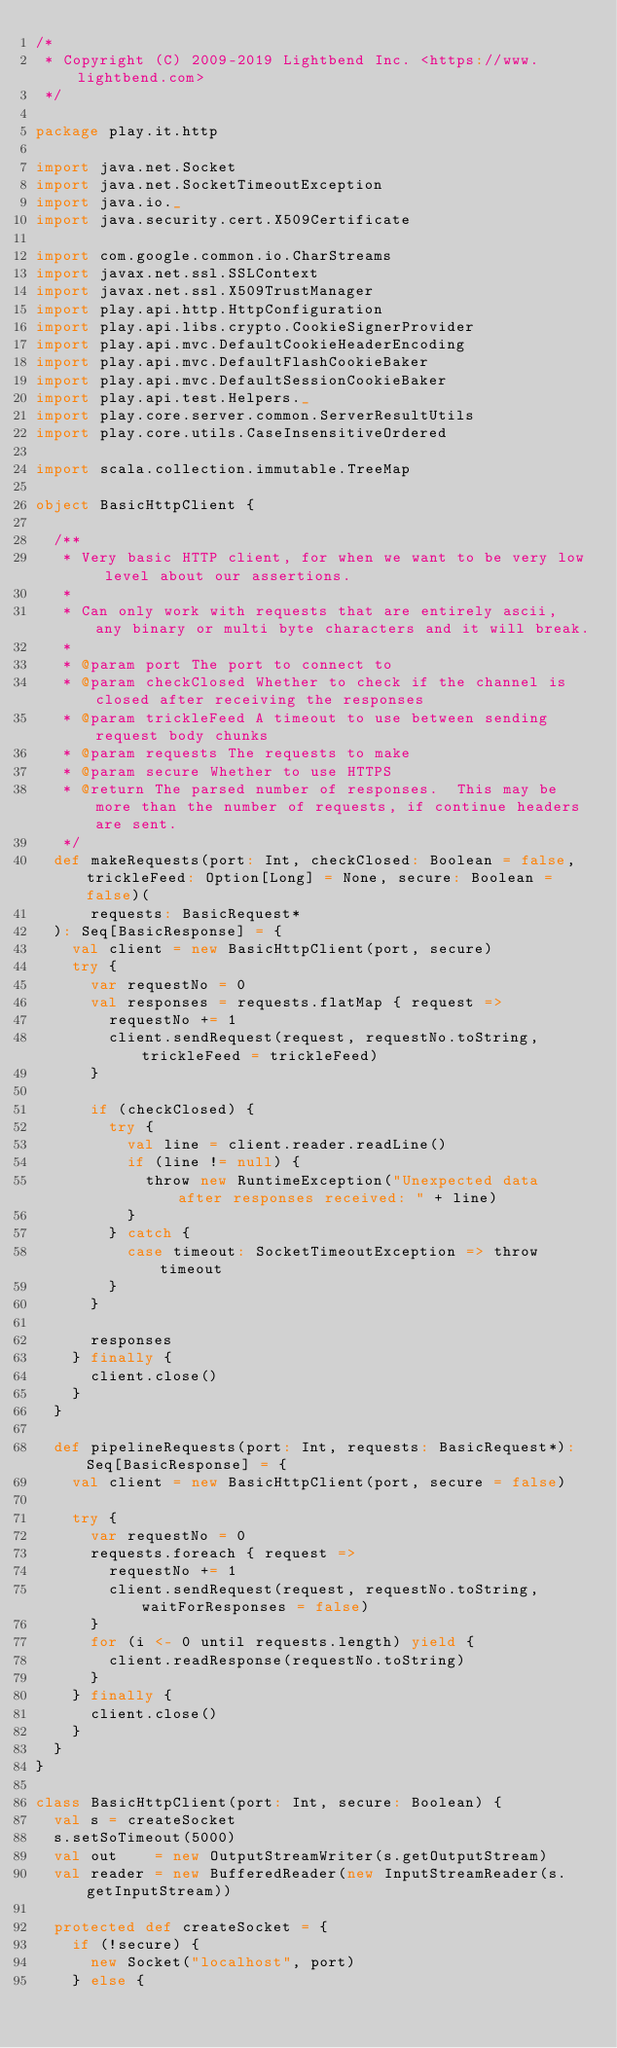<code> <loc_0><loc_0><loc_500><loc_500><_Scala_>/*
 * Copyright (C) 2009-2019 Lightbend Inc. <https://www.lightbend.com>
 */

package play.it.http

import java.net.Socket
import java.net.SocketTimeoutException
import java.io._
import java.security.cert.X509Certificate

import com.google.common.io.CharStreams
import javax.net.ssl.SSLContext
import javax.net.ssl.X509TrustManager
import play.api.http.HttpConfiguration
import play.api.libs.crypto.CookieSignerProvider
import play.api.mvc.DefaultCookieHeaderEncoding
import play.api.mvc.DefaultFlashCookieBaker
import play.api.mvc.DefaultSessionCookieBaker
import play.api.test.Helpers._
import play.core.server.common.ServerResultUtils
import play.core.utils.CaseInsensitiveOrdered

import scala.collection.immutable.TreeMap

object BasicHttpClient {

  /**
   * Very basic HTTP client, for when we want to be very low level about our assertions.
   *
   * Can only work with requests that are entirely ascii, any binary or multi byte characters and it will break.
   *
   * @param port The port to connect to
   * @param checkClosed Whether to check if the channel is closed after receiving the responses
   * @param trickleFeed A timeout to use between sending request body chunks
   * @param requests The requests to make
   * @param secure Whether to use HTTPS
   * @return The parsed number of responses.  This may be more than the number of requests, if continue headers are sent.
   */
  def makeRequests(port: Int, checkClosed: Boolean = false, trickleFeed: Option[Long] = None, secure: Boolean = false)(
      requests: BasicRequest*
  ): Seq[BasicResponse] = {
    val client = new BasicHttpClient(port, secure)
    try {
      var requestNo = 0
      val responses = requests.flatMap { request =>
        requestNo += 1
        client.sendRequest(request, requestNo.toString, trickleFeed = trickleFeed)
      }

      if (checkClosed) {
        try {
          val line = client.reader.readLine()
          if (line != null) {
            throw new RuntimeException("Unexpected data after responses received: " + line)
          }
        } catch {
          case timeout: SocketTimeoutException => throw timeout
        }
      }

      responses
    } finally {
      client.close()
    }
  }

  def pipelineRequests(port: Int, requests: BasicRequest*): Seq[BasicResponse] = {
    val client = new BasicHttpClient(port, secure = false)

    try {
      var requestNo = 0
      requests.foreach { request =>
        requestNo += 1
        client.sendRequest(request, requestNo.toString, waitForResponses = false)
      }
      for (i <- 0 until requests.length) yield {
        client.readResponse(requestNo.toString)
      }
    } finally {
      client.close()
    }
  }
}

class BasicHttpClient(port: Int, secure: Boolean) {
  val s = createSocket
  s.setSoTimeout(5000)
  val out    = new OutputStreamWriter(s.getOutputStream)
  val reader = new BufferedReader(new InputStreamReader(s.getInputStream))

  protected def createSocket = {
    if (!secure) {
      new Socket("localhost", port)
    } else {</code> 